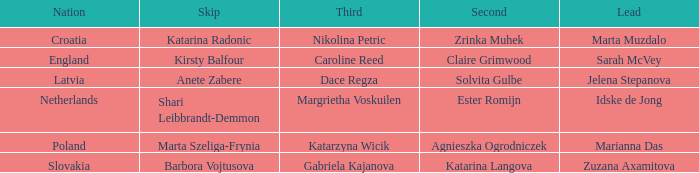Which Lead has Katarina Radonic as Skip? Marta Muzdalo. 